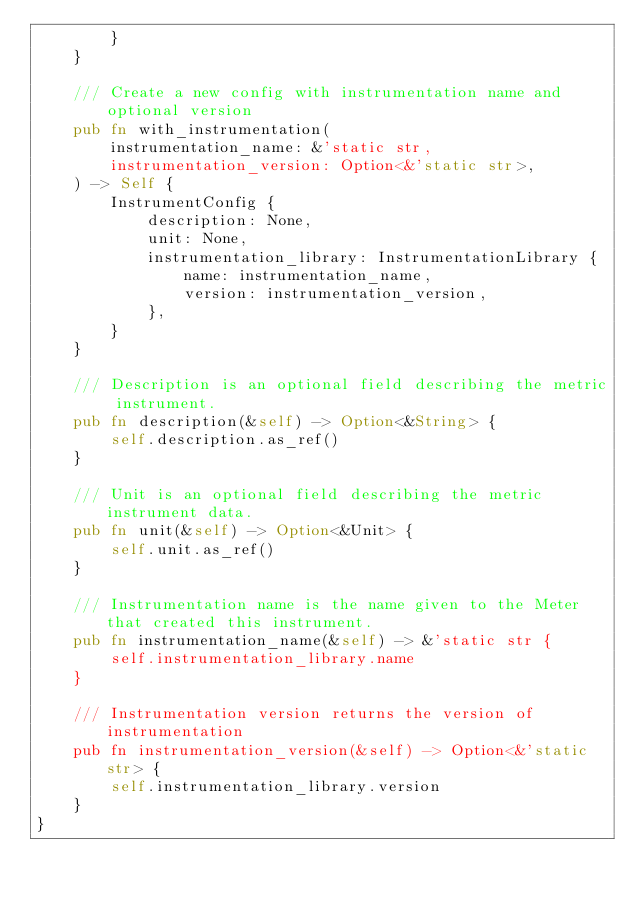<code> <loc_0><loc_0><loc_500><loc_500><_Rust_>        }
    }

    /// Create a new config with instrumentation name and optional version
    pub fn with_instrumentation(
        instrumentation_name: &'static str,
        instrumentation_version: Option<&'static str>,
    ) -> Self {
        InstrumentConfig {
            description: None,
            unit: None,
            instrumentation_library: InstrumentationLibrary {
                name: instrumentation_name,
                version: instrumentation_version,
            },
        }
    }

    /// Description is an optional field describing the metric instrument.
    pub fn description(&self) -> Option<&String> {
        self.description.as_ref()
    }

    /// Unit is an optional field describing the metric instrument data.
    pub fn unit(&self) -> Option<&Unit> {
        self.unit.as_ref()
    }

    /// Instrumentation name is the name given to the Meter that created this instrument.
    pub fn instrumentation_name(&self) -> &'static str {
        self.instrumentation_library.name
    }

    /// Instrumentation version returns the version of instrumentation
    pub fn instrumentation_version(&self) -> Option<&'static str> {
        self.instrumentation_library.version
    }
}
</code> 